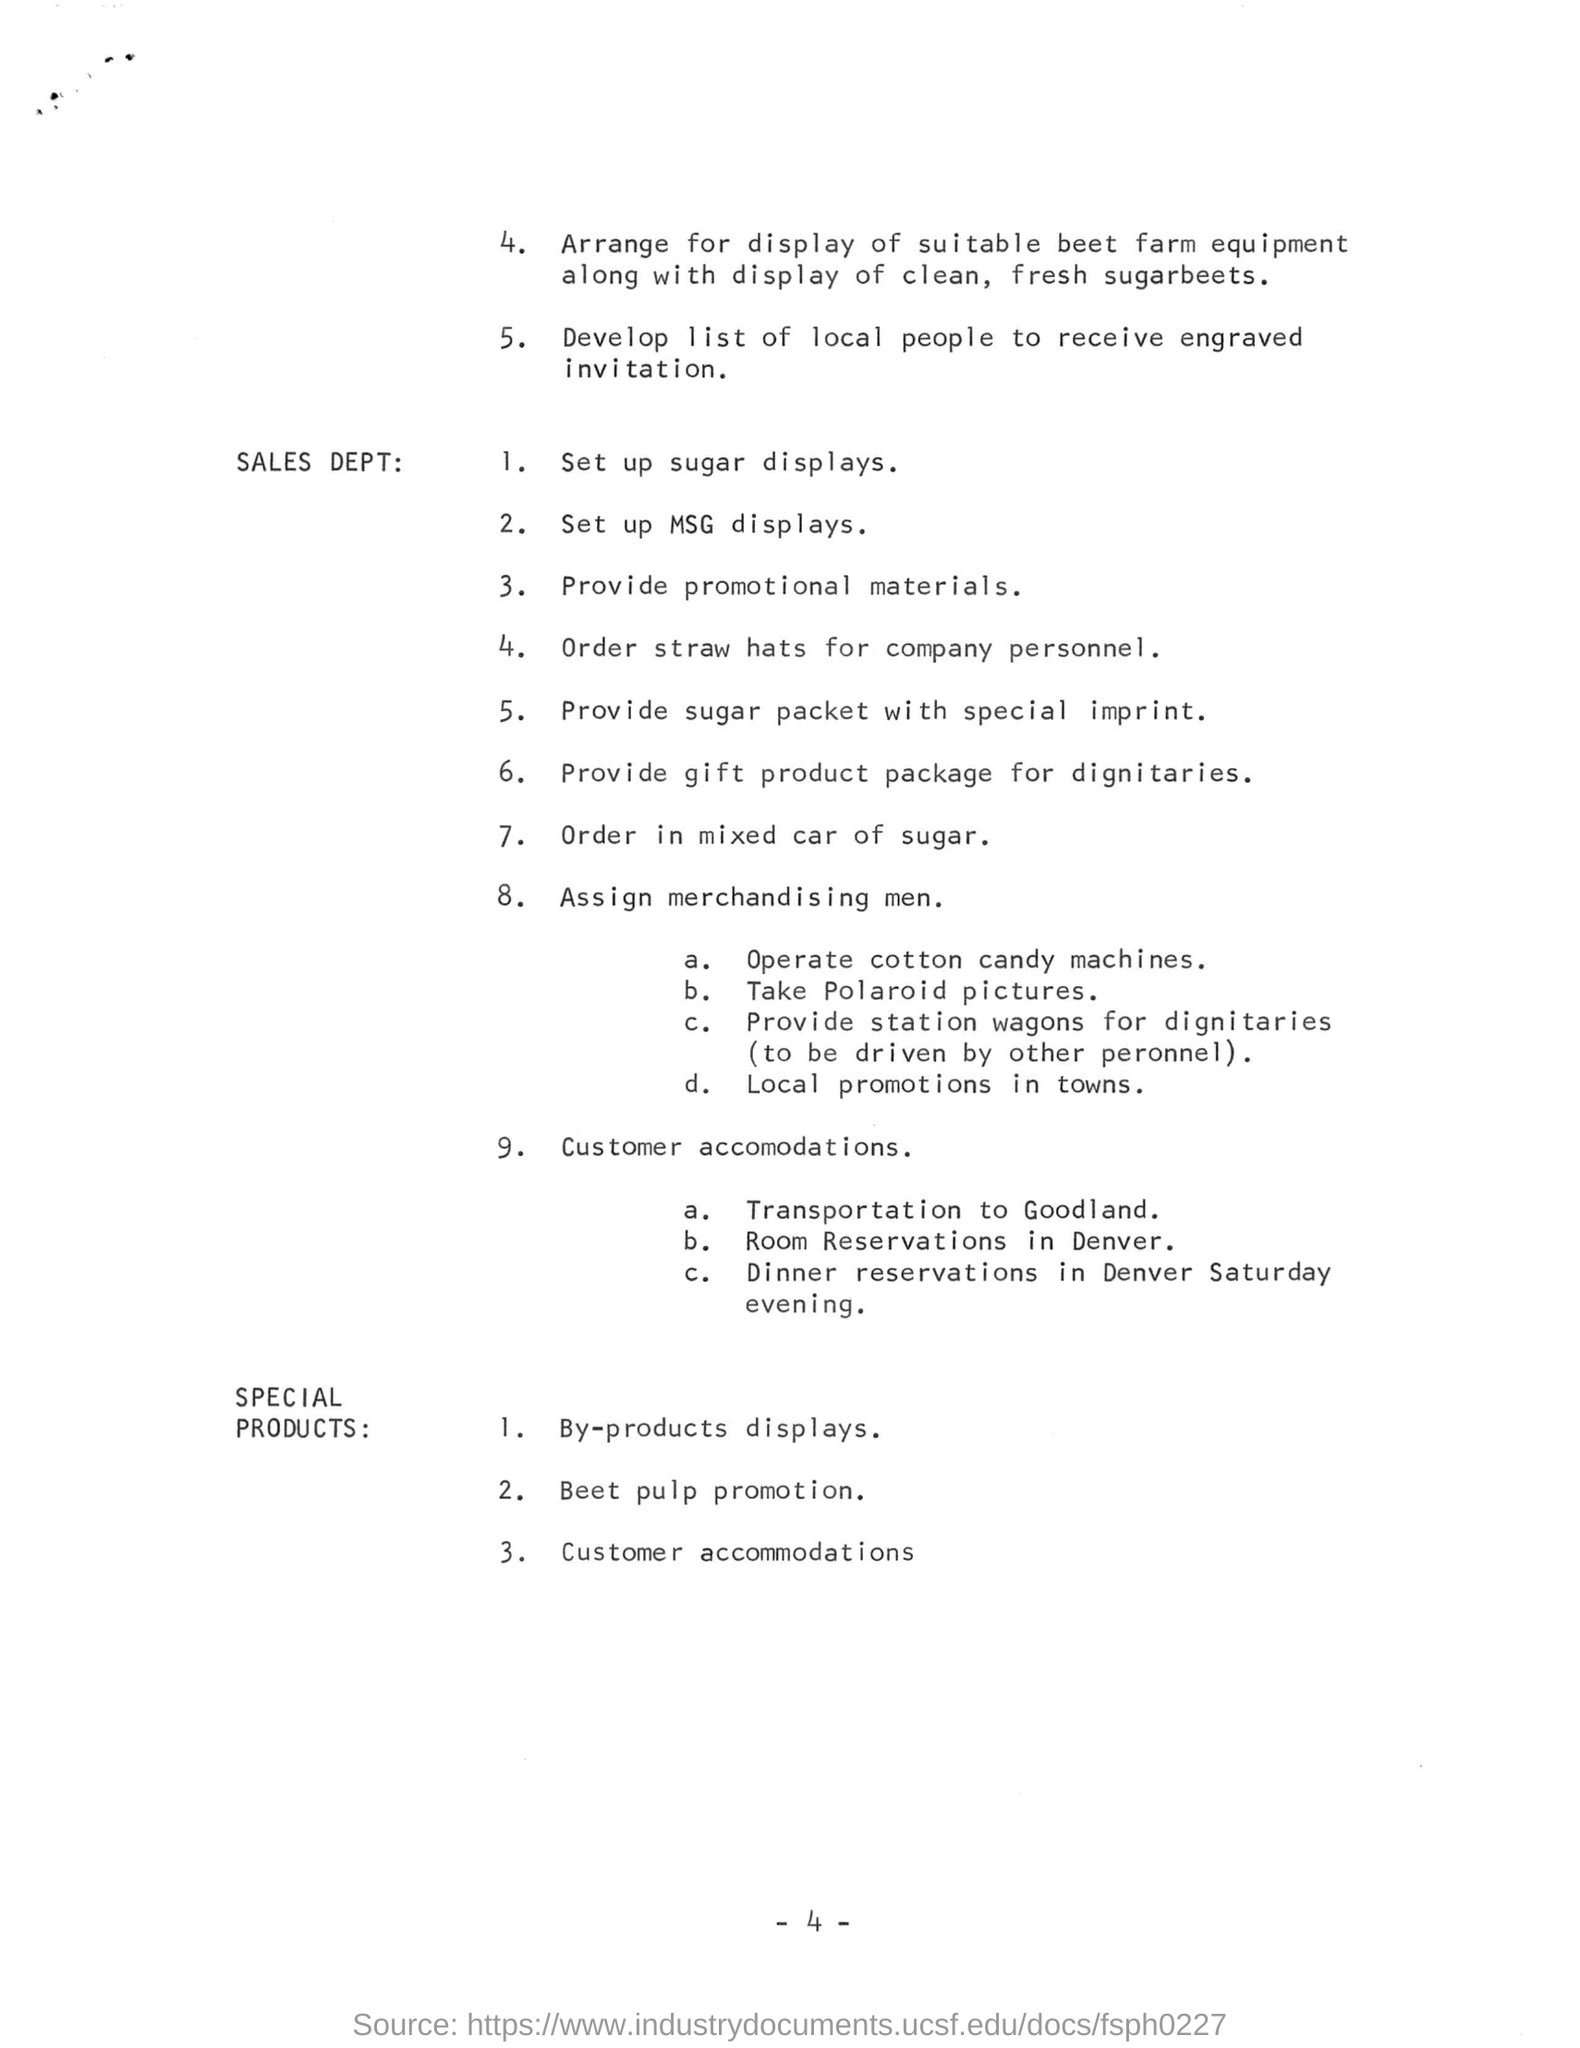Mention a couple of crucial points in this snapshot. In situations where transportation is arranged for customers, it is typically to a location known as Goodland. The promotion of beet pulp is mentioned in the SPECIAL PRODUCTS section. In the context of customer accommodation, the room reservation is typically arranged in Denver. I have observed that when clean and fresh sugar beets are displayed, suitable beet farm equipment is often arranged in close proximity. 